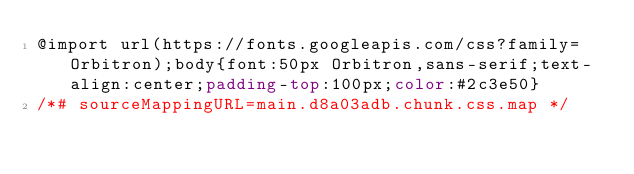<code> <loc_0><loc_0><loc_500><loc_500><_CSS_>@import url(https://fonts.googleapis.com/css?family=Orbitron);body{font:50px Orbitron,sans-serif;text-align:center;padding-top:100px;color:#2c3e50}
/*# sourceMappingURL=main.d8a03adb.chunk.css.map */</code> 